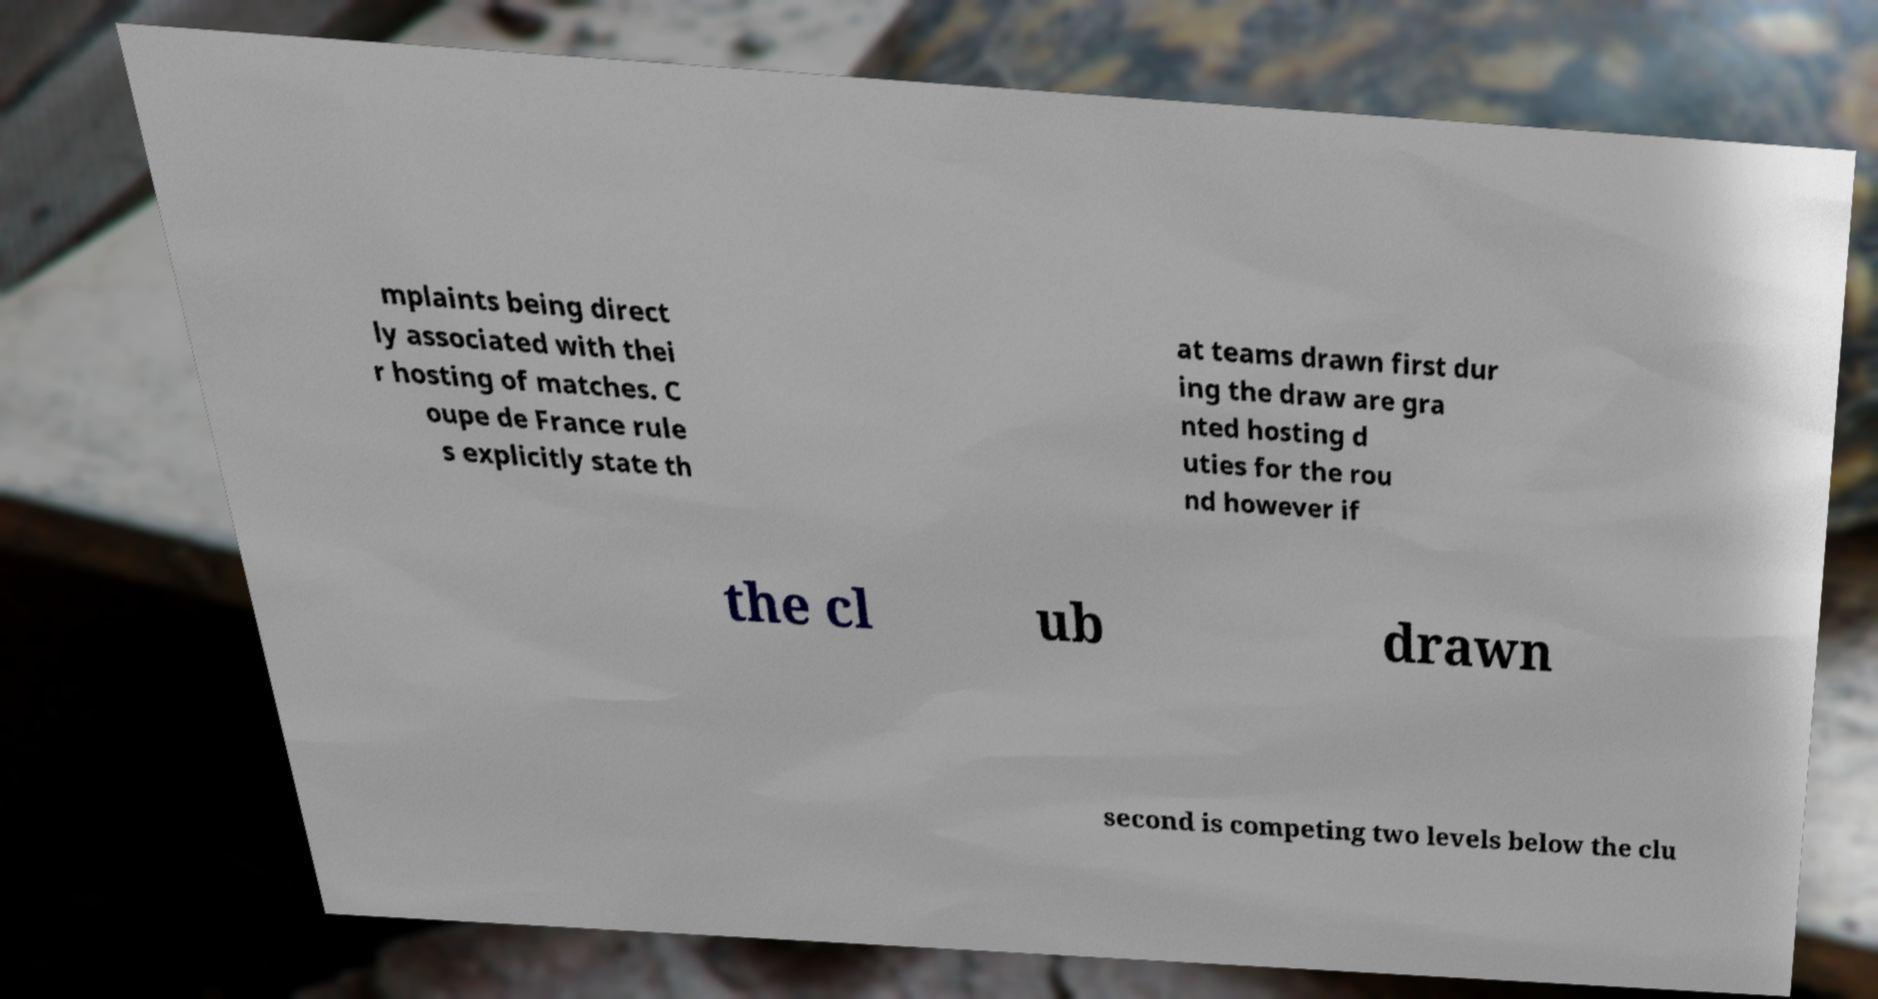Can you accurately transcribe the text from the provided image for me? mplaints being direct ly associated with thei r hosting of matches. C oupe de France rule s explicitly state th at teams drawn first dur ing the draw are gra nted hosting d uties for the rou nd however if the cl ub drawn second is competing two levels below the clu 